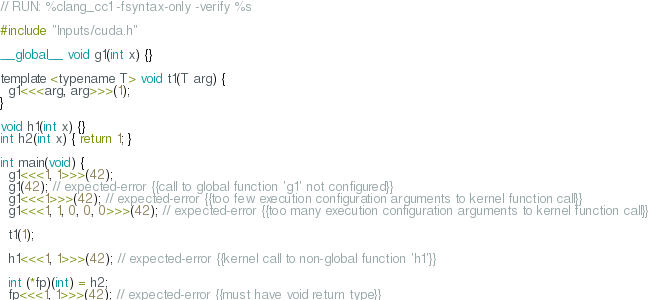<code> <loc_0><loc_0><loc_500><loc_500><_Cuda_>// RUN: %clang_cc1 -fsyntax-only -verify %s

#include "Inputs/cuda.h"

__global__ void g1(int x) {}

template <typename T> void t1(T arg) {
  g1<<<arg, arg>>>(1);
}

void h1(int x) {}
int h2(int x) { return 1; }

int main(void) {
  g1<<<1, 1>>>(42);
  g1(42); // expected-error {{call to global function 'g1' not configured}}
  g1<<<1>>>(42); // expected-error {{too few execution configuration arguments to kernel function call}}
  g1<<<1, 1, 0, 0, 0>>>(42); // expected-error {{too many execution configuration arguments to kernel function call}}

  t1(1);

  h1<<<1, 1>>>(42); // expected-error {{kernel call to non-global function 'h1'}}

  int (*fp)(int) = h2;
  fp<<<1, 1>>>(42); // expected-error {{must have void return type}}
</code> 